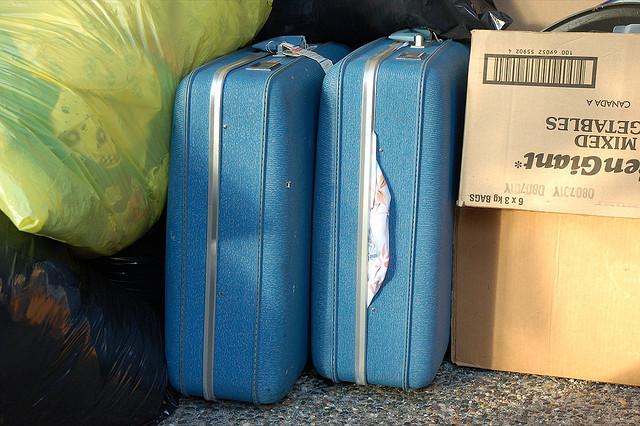Are there things sticking out of the luggage?
Quick response, please. Yes. What is the item with writing on it?
Concise answer only. Box. What are those blue items for?
Keep it brief. Luggage. 